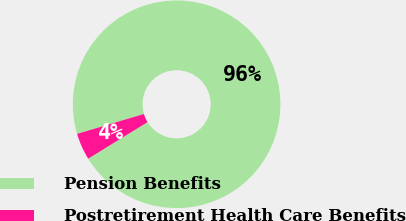Convert chart to OTSL. <chart><loc_0><loc_0><loc_500><loc_500><pie_chart><fcel>Pension Benefits<fcel>Postretirement Health Care Benefits<nl><fcel>95.82%<fcel>4.18%<nl></chart> 